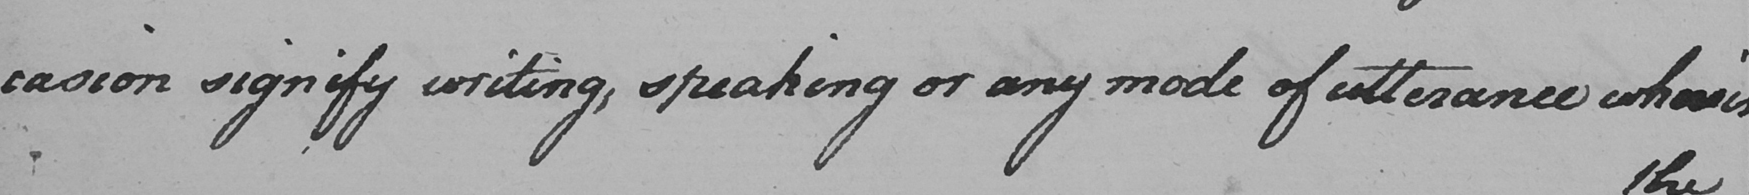Can you read and transcribe this handwriting? -casion signify writing , speaking or any mode of utterance wherein 